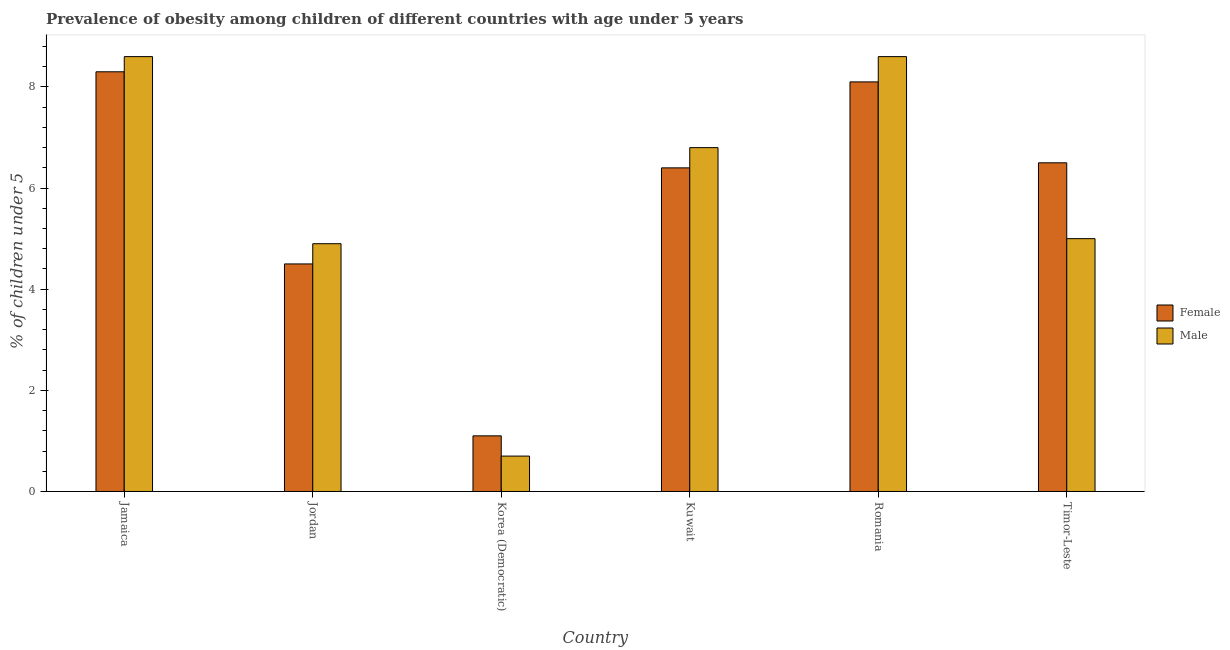How many different coloured bars are there?
Provide a short and direct response. 2. Are the number of bars on each tick of the X-axis equal?
Your response must be concise. Yes. What is the label of the 6th group of bars from the left?
Keep it short and to the point. Timor-Leste. In how many cases, is the number of bars for a given country not equal to the number of legend labels?
Provide a succinct answer. 0. Across all countries, what is the maximum percentage of obese female children?
Offer a terse response. 8.3. Across all countries, what is the minimum percentage of obese female children?
Offer a terse response. 1.1. In which country was the percentage of obese female children maximum?
Offer a terse response. Jamaica. In which country was the percentage of obese male children minimum?
Your response must be concise. Korea (Democratic). What is the total percentage of obese male children in the graph?
Offer a terse response. 34.6. What is the difference between the percentage of obese female children in Jordan and that in Timor-Leste?
Your response must be concise. -2. What is the difference between the percentage of obese male children in Jordan and the percentage of obese female children in Kuwait?
Your response must be concise. -1.5. What is the average percentage of obese female children per country?
Offer a very short reply. 5.82. What is the difference between the percentage of obese female children and percentage of obese male children in Jamaica?
Your response must be concise. -0.3. In how many countries, is the percentage of obese male children greater than 4.8 %?
Make the answer very short. 5. What is the ratio of the percentage of obese male children in Jordan to that in Korea (Democratic)?
Your response must be concise. 7. Is the difference between the percentage of obese female children in Jordan and Korea (Democratic) greater than the difference between the percentage of obese male children in Jordan and Korea (Democratic)?
Ensure brevity in your answer.  No. What is the difference between the highest and the second highest percentage of obese female children?
Offer a terse response. 0.2. What is the difference between the highest and the lowest percentage of obese female children?
Offer a terse response. 7.2. In how many countries, is the percentage of obese male children greater than the average percentage of obese male children taken over all countries?
Offer a terse response. 3. Is the sum of the percentage of obese female children in Kuwait and Romania greater than the maximum percentage of obese male children across all countries?
Provide a succinct answer. Yes. How many countries are there in the graph?
Your answer should be compact. 6. Are the values on the major ticks of Y-axis written in scientific E-notation?
Provide a succinct answer. No. Where does the legend appear in the graph?
Make the answer very short. Center right. What is the title of the graph?
Provide a succinct answer. Prevalence of obesity among children of different countries with age under 5 years. Does "Rural Population" appear as one of the legend labels in the graph?
Your answer should be compact. No. What is the label or title of the Y-axis?
Ensure brevity in your answer.   % of children under 5. What is the  % of children under 5 in Female in Jamaica?
Provide a succinct answer. 8.3. What is the  % of children under 5 of Male in Jamaica?
Offer a very short reply. 8.6. What is the  % of children under 5 in Male in Jordan?
Keep it short and to the point. 4.9. What is the  % of children under 5 of Female in Korea (Democratic)?
Keep it short and to the point. 1.1. What is the  % of children under 5 of Male in Korea (Democratic)?
Your response must be concise. 0.7. What is the  % of children under 5 of Female in Kuwait?
Keep it short and to the point. 6.4. What is the  % of children under 5 of Male in Kuwait?
Your answer should be very brief. 6.8. What is the  % of children under 5 in Female in Romania?
Your response must be concise. 8.1. What is the  % of children under 5 in Male in Romania?
Your response must be concise. 8.6. Across all countries, what is the maximum  % of children under 5 of Female?
Your answer should be compact. 8.3. Across all countries, what is the maximum  % of children under 5 of Male?
Provide a short and direct response. 8.6. Across all countries, what is the minimum  % of children under 5 of Female?
Keep it short and to the point. 1.1. Across all countries, what is the minimum  % of children under 5 in Male?
Keep it short and to the point. 0.7. What is the total  % of children under 5 of Female in the graph?
Provide a short and direct response. 34.9. What is the total  % of children under 5 of Male in the graph?
Your answer should be very brief. 34.6. What is the difference between the  % of children under 5 in Female in Jamaica and that in Jordan?
Make the answer very short. 3.8. What is the difference between the  % of children under 5 in Female in Jamaica and that in Kuwait?
Offer a very short reply. 1.9. What is the difference between the  % of children under 5 in Male in Jamaica and that in Kuwait?
Provide a succinct answer. 1.8. What is the difference between the  % of children under 5 in Male in Jamaica and that in Romania?
Give a very brief answer. 0. What is the difference between the  % of children under 5 in Male in Jamaica and that in Timor-Leste?
Keep it short and to the point. 3.6. What is the difference between the  % of children under 5 in Male in Jordan and that in Korea (Democratic)?
Ensure brevity in your answer.  4.2. What is the difference between the  % of children under 5 in Male in Jordan and that in Kuwait?
Give a very brief answer. -1.9. What is the difference between the  % of children under 5 in Female in Jordan and that in Timor-Leste?
Your answer should be very brief. -2. What is the difference between the  % of children under 5 in Male in Jordan and that in Timor-Leste?
Ensure brevity in your answer.  -0.1. What is the difference between the  % of children under 5 of Male in Korea (Democratic) and that in Kuwait?
Make the answer very short. -6.1. What is the difference between the  % of children under 5 in Male in Korea (Democratic) and that in Timor-Leste?
Your answer should be very brief. -4.3. What is the difference between the  % of children under 5 of Female in Kuwait and that in Timor-Leste?
Make the answer very short. -0.1. What is the difference between the  % of children under 5 of Male in Kuwait and that in Timor-Leste?
Provide a succinct answer. 1.8. What is the difference between the  % of children under 5 of Female in Romania and that in Timor-Leste?
Your response must be concise. 1.6. What is the difference between the  % of children under 5 of Male in Romania and that in Timor-Leste?
Make the answer very short. 3.6. What is the difference between the  % of children under 5 in Female in Jamaica and the  % of children under 5 in Male in Korea (Democratic)?
Keep it short and to the point. 7.6. What is the difference between the  % of children under 5 in Female in Jamaica and the  % of children under 5 in Male in Kuwait?
Ensure brevity in your answer.  1.5. What is the difference between the  % of children under 5 of Female in Jamaica and the  % of children under 5 of Male in Romania?
Your response must be concise. -0.3. What is the difference between the  % of children under 5 in Female in Jamaica and the  % of children under 5 in Male in Timor-Leste?
Provide a succinct answer. 3.3. What is the difference between the  % of children under 5 of Female in Jordan and the  % of children under 5 of Male in Kuwait?
Provide a short and direct response. -2.3. What is the difference between the  % of children under 5 in Female in Jordan and the  % of children under 5 in Male in Romania?
Offer a very short reply. -4.1. What is the difference between the  % of children under 5 in Female in Jordan and the  % of children under 5 in Male in Timor-Leste?
Ensure brevity in your answer.  -0.5. What is the difference between the  % of children under 5 in Female in Korea (Democratic) and the  % of children under 5 in Male in Kuwait?
Offer a very short reply. -5.7. What is the difference between the  % of children under 5 in Female in Korea (Democratic) and the  % of children under 5 in Male in Romania?
Make the answer very short. -7.5. What is the difference between the  % of children under 5 of Female in Korea (Democratic) and the  % of children under 5 of Male in Timor-Leste?
Provide a succinct answer. -3.9. What is the difference between the  % of children under 5 of Female in Kuwait and the  % of children under 5 of Male in Romania?
Your response must be concise. -2.2. What is the average  % of children under 5 in Female per country?
Offer a terse response. 5.82. What is the average  % of children under 5 of Male per country?
Your answer should be very brief. 5.77. What is the difference between the  % of children under 5 of Female and  % of children under 5 of Male in Jamaica?
Keep it short and to the point. -0.3. What is the difference between the  % of children under 5 of Female and  % of children under 5 of Male in Jordan?
Your answer should be compact. -0.4. What is the difference between the  % of children under 5 in Female and  % of children under 5 in Male in Kuwait?
Provide a succinct answer. -0.4. What is the difference between the  % of children under 5 in Female and  % of children under 5 in Male in Romania?
Keep it short and to the point. -0.5. What is the difference between the  % of children under 5 in Female and  % of children under 5 in Male in Timor-Leste?
Give a very brief answer. 1.5. What is the ratio of the  % of children under 5 in Female in Jamaica to that in Jordan?
Offer a very short reply. 1.84. What is the ratio of the  % of children under 5 in Male in Jamaica to that in Jordan?
Your answer should be very brief. 1.76. What is the ratio of the  % of children under 5 in Female in Jamaica to that in Korea (Democratic)?
Provide a succinct answer. 7.55. What is the ratio of the  % of children under 5 of Male in Jamaica to that in Korea (Democratic)?
Your response must be concise. 12.29. What is the ratio of the  % of children under 5 in Female in Jamaica to that in Kuwait?
Your response must be concise. 1.3. What is the ratio of the  % of children under 5 of Male in Jamaica to that in Kuwait?
Your answer should be compact. 1.26. What is the ratio of the  % of children under 5 of Female in Jamaica to that in Romania?
Make the answer very short. 1.02. What is the ratio of the  % of children under 5 in Female in Jamaica to that in Timor-Leste?
Ensure brevity in your answer.  1.28. What is the ratio of the  % of children under 5 in Male in Jamaica to that in Timor-Leste?
Your answer should be compact. 1.72. What is the ratio of the  % of children under 5 of Female in Jordan to that in Korea (Democratic)?
Offer a very short reply. 4.09. What is the ratio of the  % of children under 5 of Female in Jordan to that in Kuwait?
Offer a terse response. 0.7. What is the ratio of the  % of children under 5 in Male in Jordan to that in Kuwait?
Make the answer very short. 0.72. What is the ratio of the  % of children under 5 in Female in Jordan to that in Romania?
Your answer should be very brief. 0.56. What is the ratio of the  % of children under 5 of Male in Jordan to that in Romania?
Offer a terse response. 0.57. What is the ratio of the  % of children under 5 of Female in Jordan to that in Timor-Leste?
Make the answer very short. 0.69. What is the ratio of the  % of children under 5 in Male in Jordan to that in Timor-Leste?
Keep it short and to the point. 0.98. What is the ratio of the  % of children under 5 in Female in Korea (Democratic) to that in Kuwait?
Offer a terse response. 0.17. What is the ratio of the  % of children under 5 in Male in Korea (Democratic) to that in Kuwait?
Offer a very short reply. 0.1. What is the ratio of the  % of children under 5 in Female in Korea (Democratic) to that in Romania?
Your answer should be compact. 0.14. What is the ratio of the  % of children under 5 of Male in Korea (Democratic) to that in Romania?
Keep it short and to the point. 0.08. What is the ratio of the  % of children under 5 in Female in Korea (Democratic) to that in Timor-Leste?
Your answer should be compact. 0.17. What is the ratio of the  % of children under 5 in Male in Korea (Democratic) to that in Timor-Leste?
Provide a short and direct response. 0.14. What is the ratio of the  % of children under 5 in Female in Kuwait to that in Romania?
Provide a short and direct response. 0.79. What is the ratio of the  % of children under 5 of Male in Kuwait to that in Romania?
Make the answer very short. 0.79. What is the ratio of the  % of children under 5 of Female in Kuwait to that in Timor-Leste?
Provide a succinct answer. 0.98. What is the ratio of the  % of children under 5 of Male in Kuwait to that in Timor-Leste?
Offer a terse response. 1.36. What is the ratio of the  % of children under 5 of Female in Romania to that in Timor-Leste?
Make the answer very short. 1.25. What is the ratio of the  % of children under 5 of Male in Romania to that in Timor-Leste?
Provide a short and direct response. 1.72. What is the difference between the highest and the second highest  % of children under 5 of Male?
Your answer should be very brief. 0. What is the difference between the highest and the lowest  % of children under 5 of Male?
Ensure brevity in your answer.  7.9. 